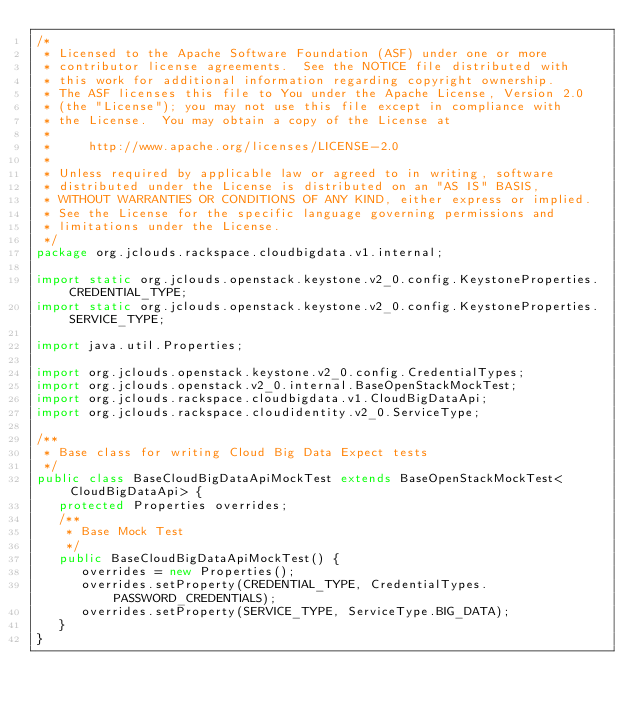Convert code to text. <code><loc_0><loc_0><loc_500><loc_500><_Java_>/*
 * Licensed to the Apache Software Foundation (ASF) under one or more
 * contributor license agreements.  See the NOTICE file distributed with
 * this work for additional information regarding copyright ownership.
 * The ASF licenses this file to You under the Apache License, Version 2.0
 * (the "License"); you may not use this file except in compliance with
 * the License.  You may obtain a copy of the License at
 *
 *     http://www.apache.org/licenses/LICENSE-2.0
 *
 * Unless required by applicable law or agreed to in writing, software
 * distributed under the License is distributed on an "AS IS" BASIS,
 * WITHOUT WARRANTIES OR CONDITIONS OF ANY KIND, either express or implied.
 * See the License for the specific language governing permissions and
 * limitations under the License.
 */
package org.jclouds.rackspace.cloudbigdata.v1.internal;

import static org.jclouds.openstack.keystone.v2_0.config.KeystoneProperties.CREDENTIAL_TYPE;
import static org.jclouds.openstack.keystone.v2_0.config.KeystoneProperties.SERVICE_TYPE;

import java.util.Properties;

import org.jclouds.openstack.keystone.v2_0.config.CredentialTypes;
import org.jclouds.openstack.v2_0.internal.BaseOpenStackMockTest;
import org.jclouds.rackspace.cloudbigdata.v1.CloudBigDataApi;
import org.jclouds.rackspace.cloudidentity.v2_0.ServiceType;

/**
 * Base class for writing Cloud Big Data Expect tests
 */
public class BaseCloudBigDataApiMockTest extends BaseOpenStackMockTest<CloudBigDataApi> {
   protected Properties overrides;
   /**
    * Base Mock Test
    */
   public BaseCloudBigDataApiMockTest() {
      overrides = new Properties();
      overrides.setProperty(CREDENTIAL_TYPE, CredentialTypes.PASSWORD_CREDENTIALS);
      overrides.setProperty(SERVICE_TYPE, ServiceType.BIG_DATA);
   }
}
</code> 